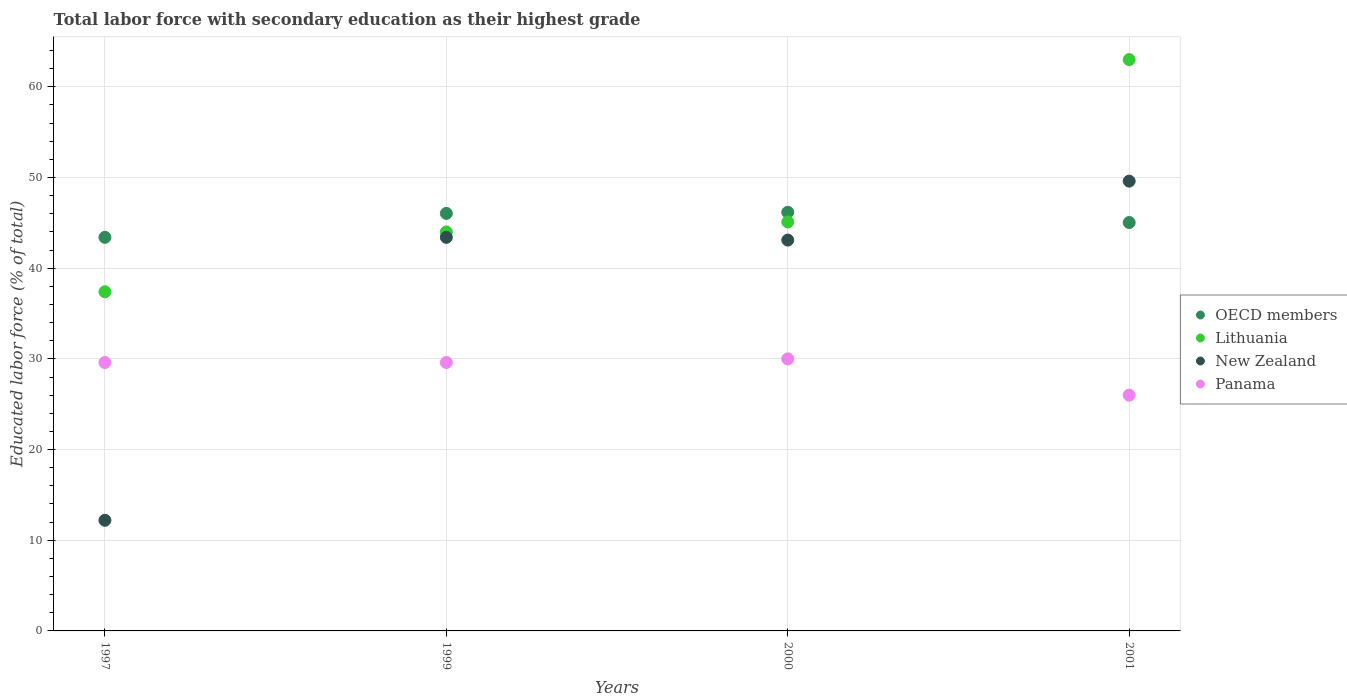Is the number of dotlines equal to the number of legend labels?
Your answer should be compact. Yes. What is the percentage of total labor force with primary education in New Zealand in 2001?
Provide a succinct answer. 49.6. In which year was the percentage of total labor force with primary education in Panama minimum?
Your answer should be very brief. 2001. What is the total percentage of total labor force with primary education in New Zealand in the graph?
Ensure brevity in your answer.  148.3. What is the difference between the percentage of total labor force with primary education in New Zealand in 1999 and that in 2000?
Give a very brief answer. 0.3. What is the average percentage of total labor force with primary education in Lithuania per year?
Provide a short and direct response. 47.38. In the year 1999, what is the difference between the percentage of total labor force with primary education in Panama and percentage of total labor force with primary education in New Zealand?
Your answer should be compact. -13.8. What is the ratio of the percentage of total labor force with primary education in Panama in 1997 to that in 2001?
Give a very brief answer. 1.14. Is the difference between the percentage of total labor force with primary education in Panama in 1997 and 2001 greater than the difference between the percentage of total labor force with primary education in New Zealand in 1997 and 2001?
Make the answer very short. Yes. What is the difference between the highest and the second highest percentage of total labor force with primary education in OECD members?
Your answer should be compact. 0.12. What is the difference between the highest and the lowest percentage of total labor force with primary education in OECD members?
Ensure brevity in your answer.  2.76. In how many years, is the percentage of total labor force with primary education in Lithuania greater than the average percentage of total labor force with primary education in Lithuania taken over all years?
Offer a terse response. 1. Are the values on the major ticks of Y-axis written in scientific E-notation?
Your response must be concise. No. Does the graph contain any zero values?
Your response must be concise. No. Does the graph contain grids?
Give a very brief answer. Yes. Where does the legend appear in the graph?
Provide a short and direct response. Center right. How many legend labels are there?
Provide a short and direct response. 4. How are the legend labels stacked?
Your response must be concise. Vertical. What is the title of the graph?
Offer a terse response. Total labor force with secondary education as their highest grade. Does "East Asia (developing only)" appear as one of the legend labels in the graph?
Your answer should be very brief. No. What is the label or title of the X-axis?
Offer a very short reply. Years. What is the label or title of the Y-axis?
Offer a very short reply. Educated labor force (% of total). What is the Educated labor force (% of total) in OECD members in 1997?
Your answer should be compact. 43.4. What is the Educated labor force (% of total) in Lithuania in 1997?
Your response must be concise. 37.4. What is the Educated labor force (% of total) in New Zealand in 1997?
Your answer should be compact. 12.2. What is the Educated labor force (% of total) of Panama in 1997?
Ensure brevity in your answer.  29.6. What is the Educated labor force (% of total) in OECD members in 1999?
Ensure brevity in your answer.  46.04. What is the Educated labor force (% of total) of New Zealand in 1999?
Offer a very short reply. 43.4. What is the Educated labor force (% of total) of Panama in 1999?
Give a very brief answer. 29.6. What is the Educated labor force (% of total) in OECD members in 2000?
Give a very brief answer. 46.16. What is the Educated labor force (% of total) of Lithuania in 2000?
Offer a very short reply. 45.1. What is the Educated labor force (% of total) of New Zealand in 2000?
Make the answer very short. 43.1. What is the Educated labor force (% of total) of Panama in 2000?
Provide a succinct answer. 30. What is the Educated labor force (% of total) of OECD members in 2001?
Your answer should be compact. 45.04. What is the Educated labor force (% of total) in New Zealand in 2001?
Offer a terse response. 49.6. Across all years, what is the maximum Educated labor force (% of total) of OECD members?
Keep it short and to the point. 46.16. Across all years, what is the maximum Educated labor force (% of total) in Lithuania?
Keep it short and to the point. 63. Across all years, what is the maximum Educated labor force (% of total) in New Zealand?
Provide a short and direct response. 49.6. Across all years, what is the maximum Educated labor force (% of total) in Panama?
Your answer should be very brief. 30. Across all years, what is the minimum Educated labor force (% of total) in OECD members?
Give a very brief answer. 43.4. Across all years, what is the minimum Educated labor force (% of total) of Lithuania?
Keep it short and to the point. 37.4. Across all years, what is the minimum Educated labor force (% of total) in New Zealand?
Offer a very short reply. 12.2. What is the total Educated labor force (% of total) in OECD members in the graph?
Offer a very short reply. 180.64. What is the total Educated labor force (% of total) in Lithuania in the graph?
Provide a short and direct response. 189.5. What is the total Educated labor force (% of total) in New Zealand in the graph?
Provide a short and direct response. 148.3. What is the total Educated labor force (% of total) of Panama in the graph?
Your answer should be compact. 115.2. What is the difference between the Educated labor force (% of total) in OECD members in 1997 and that in 1999?
Keep it short and to the point. -2.64. What is the difference between the Educated labor force (% of total) of Lithuania in 1997 and that in 1999?
Offer a terse response. -6.6. What is the difference between the Educated labor force (% of total) in New Zealand in 1997 and that in 1999?
Your response must be concise. -31.2. What is the difference between the Educated labor force (% of total) in OECD members in 1997 and that in 2000?
Your answer should be very brief. -2.76. What is the difference between the Educated labor force (% of total) in New Zealand in 1997 and that in 2000?
Provide a succinct answer. -30.9. What is the difference between the Educated labor force (% of total) of OECD members in 1997 and that in 2001?
Provide a short and direct response. -1.63. What is the difference between the Educated labor force (% of total) in Lithuania in 1997 and that in 2001?
Make the answer very short. -25.6. What is the difference between the Educated labor force (% of total) of New Zealand in 1997 and that in 2001?
Your response must be concise. -37.4. What is the difference between the Educated labor force (% of total) in Panama in 1997 and that in 2001?
Offer a terse response. 3.6. What is the difference between the Educated labor force (% of total) in OECD members in 1999 and that in 2000?
Make the answer very short. -0.12. What is the difference between the Educated labor force (% of total) in Panama in 1999 and that in 2000?
Your response must be concise. -0.4. What is the difference between the Educated labor force (% of total) in OECD members in 1999 and that in 2001?
Offer a very short reply. 1.01. What is the difference between the Educated labor force (% of total) in New Zealand in 1999 and that in 2001?
Your answer should be compact. -6.2. What is the difference between the Educated labor force (% of total) in Panama in 1999 and that in 2001?
Your answer should be compact. 3.6. What is the difference between the Educated labor force (% of total) in OECD members in 2000 and that in 2001?
Your response must be concise. 1.13. What is the difference between the Educated labor force (% of total) in Lithuania in 2000 and that in 2001?
Your response must be concise. -17.9. What is the difference between the Educated labor force (% of total) in Panama in 2000 and that in 2001?
Ensure brevity in your answer.  4. What is the difference between the Educated labor force (% of total) of OECD members in 1997 and the Educated labor force (% of total) of Lithuania in 1999?
Make the answer very short. -0.6. What is the difference between the Educated labor force (% of total) in OECD members in 1997 and the Educated labor force (% of total) in New Zealand in 1999?
Provide a succinct answer. 0. What is the difference between the Educated labor force (% of total) of OECD members in 1997 and the Educated labor force (% of total) of Panama in 1999?
Provide a short and direct response. 13.8. What is the difference between the Educated labor force (% of total) in Lithuania in 1997 and the Educated labor force (% of total) in Panama in 1999?
Offer a terse response. 7.8. What is the difference between the Educated labor force (% of total) of New Zealand in 1997 and the Educated labor force (% of total) of Panama in 1999?
Offer a very short reply. -17.4. What is the difference between the Educated labor force (% of total) in OECD members in 1997 and the Educated labor force (% of total) in Lithuania in 2000?
Keep it short and to the point. -1.7. What is the difference between the Educated labor force (% of total) of OECD members in 1997 and the Educated labor force (% of total) of New Zealand in 2000?
Provide a succinct answer. 0.3. What is the difference between the Educated labor force (% of total) of OECD members in 1997 and the Educated labor force (% of total) of Panama in 2000?
Ensure brevity in your answer.  13.4. What is the difference between the Educated labor force (% of total) in Lithuania in 1997 and the Educated labor force (% of total) in New Zealand in 2000?
Give a very brief answer. -5.7. What is the difference between the Educated labor force (% of total) of New Zealand in 1997 and the Educated labor force (% of total) of Panama in 2000?
Provide a succinct answer. -17.8. What is the difference between the Educated labor force (% of total) of OECD members in 1997 and the Educated labor force (% of total) of Lithuania in 2001?
Make the answer very short. -19.6. What is the difference between the Educated labor force (% of total) of OECD members in 1997 and the Educated labor force (% of total) of New Zealand in 2001?
Your response must be concise. -6.2. What is the difference between the Educated labor force (% of total) of OECD members in 1997 and the Educated labor force (% of total) of Panama in 2001?
Ensure brevity in your answer.  17.4. What is the difference between the Educated labor force (% of total) in New Zealand in 1997 and the Educated labor force (% of total) in Panama in 2001?
Your answer should be compact. -13.8. What is the difference between the Educated labor force (% of total) of OECD members in 1999 and the Educated labor force (% of total) of Lithuania in 2000?
Provide a succinct answer. 0.94. What is the difference between the Educated labor force (% of total) of OECD members in 1999 and the Educated labor force (% of total) of New Zealand in 2000?
Ensure brevity in your answer.  2.94. What is the difference between the Educated labor force (% of total) in OECD members in 1999 and the Educated labor force (% of total) in Panama in 2000?
Ensure brevity in your answer.  16.04. What is the difference between the Educated labor force (% of total) in Lithuania in 1999 and the Educated labor force (% of total) in Panama in 2000?
Your response must be concise. 14. What is the difference between the Educated labor force (% of total) in New Zealand in 1999 and the Educated labor force (% of total) in Panama in 2000?
Your response must be concise. 13.4. What is the difference between the Educated labor force (% of total) in OECD members in 1999 and the Educated labor force (% of total) in Lithuania in 2001?
Provide a succinct answer. -16.96. What is the difference between the Educated labor force (% of total) in OECD members in 1999 and the Educated labor force (% of total) in New Zealand in 2001?
Your answer should be very brief. -3.56. What is the difference between the Educated labor force (% of total) of OECD members in 1999 and the Educated labor force (% of total) of Panama in 2001?
Give a very brief answer. 20.04. What is the difference between the Educated labor force (% of total) of Lithuania in 1999 and the Educated labor force (% of total) of Panama in 2001?
Provide a succinct answer. 18. What is the difference between the Educated labor force (% of total) in OECD members in 2000 and the Educated labor force (% of total) in Lithuania in 2001?
Your answer should be compact. -16.84. What is the difference between the Educated labor force (% of total) in OECD members in 2000 and the Educated labor force (% of total) in New Zealand in 2001?
Your answer should be very brief. -3.44. What is the difference between the Educated labor force (% of total) of OECD members in 2000 and the Educated labor force (% of total) of Panama in 2001?
Your answer should be compact. 20.16. What is the difference between the Educated labor force (% of total) in Lithuania in 2000 and the Educated labor force (% of total) in New Zealand in 2001?
Ensure brevity in your answer.  -4.5. What is the average Educated labor force (% of total) in OECD members per year?
Provide a succinct answer. 45.16. What is the average Educated labor force (% of total) in Lithuania per year?
Make the answer very short. 47.38. What is the average Educated labor force (% of total) in New Zealand per year?
Give a very brief answer. 37.08. What is the average Educated labor force (% of total) of Panama per year?
Your answer should be compact. 28.8. In the year 1997, what is the difference between the Educated labor force (% of total) of OECD members and Educated labor force (% of total) of Lithuania?
Provide a succinct answer. 6. In the year 1997, what is the difference between the Educated labor force (% of total) of OECD members and Educated labor force (% of total) of New Zealand?
Your response must be concise. 31.2. In the year 1997, what is the difference between the Educated labor force (% of total) of OECD members and Educated labor force (% of total) of Panama?
Your answer should be very brief. 13.8. In the year 1997, what is the difference between the Educated labor force (% of total) in Lithuania and Educated labor force (% of total) in New Zealand?
Your answer should be very brief. 25.2. In the year 1997, what is the difference between the Educated labor force (% of total) of New Zealand and Educated labor force (% of total) of Panama?
Keep it short and to the point. -17.4. In the year 1999, what is the difference between the Educated labor force (% of total) of OECD members and Educated labor force (% of total) of Lithuania?
Make the answer very short. 2.04. In the year 1999, what is the difference between the Educated labor force (% of total) in OECD members and Educated labor force (% of total) in New Zealand?
Make the answer very short. 2.64. In the year 1999, what is the difference between the Educated labor force (% of total) in OECD members and Educated labor force (% of total) in Panama?
Your answer should be very brief. 16.44. In the year 1999, what is the difference between the Educated labor force (% of total) of Lithuania and Educated labor force (% of total) of New Zealand?
Keep it short and to the point. 0.6. In the year 1999, what is the difference between the Educated labor force (% of total) in New Zealand and Educated labor force (% of total) in Panama?
Your answer should be very brief. 13.8. In the year 2000, what is the difference between the Educated labor force (% of total) of OECD members and Educated labor force (% of total) of Lithuania?
Your answer should be very brief. 1.06. In the year 2000, what is the difference between the Educated labor force (% of total) of OECD members and Educated labor force (% of total) of New Zealand?
Provide a short and direct response. 3.06. In the year 2000, what is the difference between the Educated labor force (% of total) of OECD members and Educated labor force (% of total) of Panama?
Your response must be concise. 16.16. In the year 2000, what is the difference between the Educated labor force (% of total) in Lithuania and Educated labor force (% of total) in New Zealand?
Offer a terse response. 2. In the year 2001, what is the difference between the Educated labor force (% of total) in OECD members and Educated labor force (% of total) in Lithuania?
Make the answer very short. -17.96. In the year 2001, what is the difference between the Educated labor force (% of total) in OECD members and Educated labor force (% of total) in New Zealand?
Offer a terse response. -4.56. In the year 2001, what is the difference between the Educated labor force (% of total) in OECD members and Educated labor force (% of total) in Panama?
Your answer should be compact. 19.04. In the year 2001, what is the difference between the Educated labor force (% of total) in Lithuania and Educated labor force (% of total) in Panama?
Offer a very short reply. 37. In the year 2001, what is the difference between the Educated labor force (% of total) in New Zealand and Educated labor force (% of total) in Panama?
Your response must be concise. 23.6. What is the ratio of the Educated labor force (% of total) of OECD members in 1997 to that in 1999?
Keep it short and to the point. 0.94. What is the ratio of the Educated labor force (% of total) of New Zealand in 1997 to that in 1999?
Provide a short and direct response. 0.28. What is the ratio of the Educated labor force (% of total) in OECD members in 1997 to that in 2000?
Offer a terse response. 0.94. What is the ratio of the Educated labor force (% of total) of Lithuania in 1997 to that in 2000?
Make the answer very short. 0.83. What is the ratio of the Educated labor force (% of total) of New Zealand in 1997 to that in 2000?
Your answer should be very brief. 0.28. What is the ratio of the Educated labor force (% of total) in Panama in 1997 to that in 2000?
Give a very brief answer. 0.99. What is the ratio of the Educated labor force (% of total) of OECD members in 1997 to that in 2001?
Your response must be concise. 0.96. What is the ratio of the Educated labor force (% of total) of Lithuania in 1997 to that in 2001?
Your answer should be compact. 0.59. What is the ratio of the Educated labor force (% of total) in New Zealand in 1997 to that in 2001?
Your response must be concise. 0.25. What is the ratio of the Educated labor force (% of total) of Panama in 1997 to that in 2001?
Make the answer very short. 1.14. What is the ratio of the Educated labor force (% of total) of OECD members in 1999 to that in 2000?
Provide a succinct answer. 1. What is the ratio of the Educated labor force (% of total) in Lithuania in 1999 to that in 2000?
Your response must be concise. 0.98. What is the ratio of the Educated labor force (% of total) of New Zealand in 1999 to that in 2000?
Provide a succinct answer. 1.01. What is the ratio of the Educated labor force (% of total) in Panama in 1999 to that in 2000?
Offer a very short reply. 0.99. What is the ratio of the Educated labor force (% of total) of OECD members in 1999 to that in 2001?
Your response must be concise. 1.02. What is the ratio of the Educated labor force (% of total) in Lithuania in 1999 to that in 2001?
Give a very brief answer. 0.7. What is the ratio of the Educated labor force (% of total) in New Zealand in 1999 to that in 2001?
Offer a terse response. 0.88. What is the ratio of the Educated labor force (% of total) of Panama in 1999 to that in 2001?
Provide a short and direct response. 1.14. What is the ratio of the Educated labor force (% of total) in OECD members in 2000 to that in 2001?
Ensure brevity in your answer.  1.03. What is the ratio of the Educated labor force (% of total) in Lithuania in 2000 to that in 2001?
Offer a terse response. 0.72. What is the ratio of the Educated labor force (% of total) in New Zealand in 2000 to that in 2001?
Keep it short and to the point. 0.87. What is the ratio of the Educated labor force (% of total) in Panama in 2000 to that in 2001?
Ensure brevity in your answer.  1.15. What is the difference between the highest and the second highest Educated labor force (% of total) of OECD members?
Your response must be concise. 0.12. What is the difference between the highest and the second highest Educated labor force (% of total) in Panama?
Provide a short and direct response. 0.4. What is the difference between the highest and the lowest Educated labor force (% of total) in OECD members?
Make the answer very short. 2.76. What is the difference between the highest and the lowest Educated labor force (% of total) of Lithuania?
Your answer should be very brief. 25.6. What is the difference between the highest and the lowest Educated labor force (% of total) of New Zealand?
Make the answer very short. 37.4. What is the difference between the highest and the lowest Educated labor force (% of total) in Panama?
Provide a short and direct response. 4. 